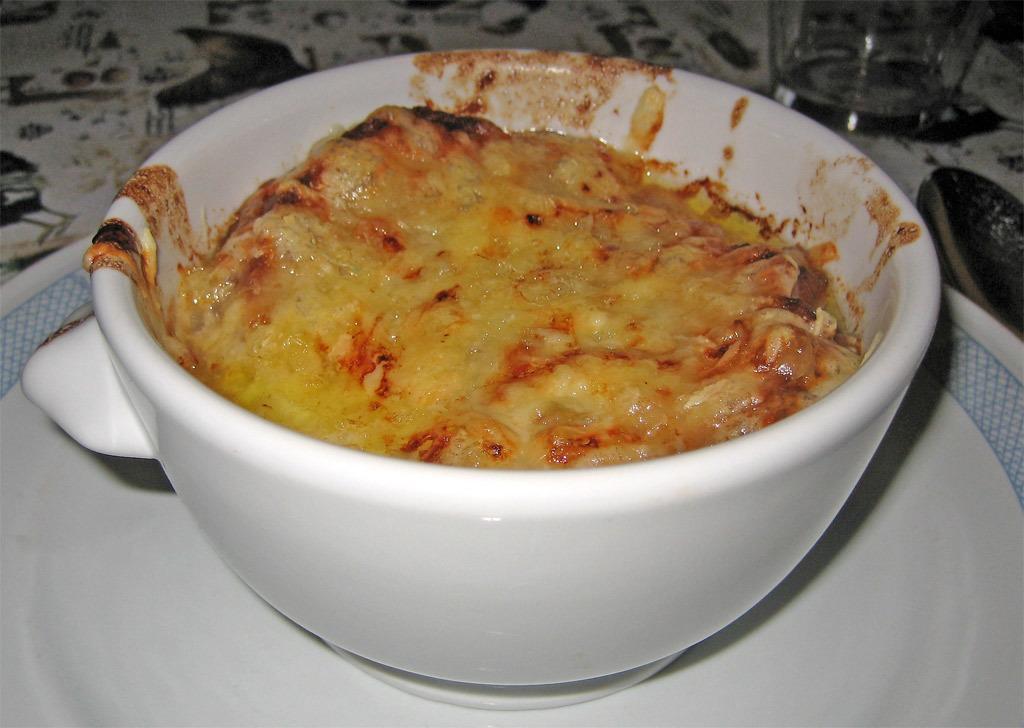How would you summarize this image in a sentence or two? In this image we can see some food in the bowl. We can see the ball is placed on the plate. There is a drinking glass and a spoon at the right side of the image. 